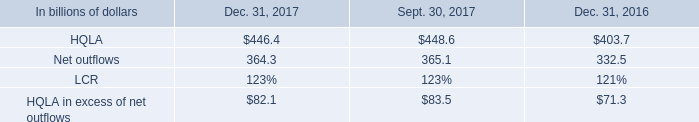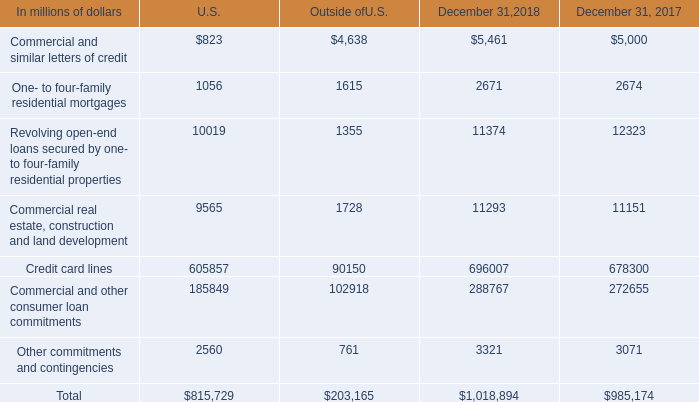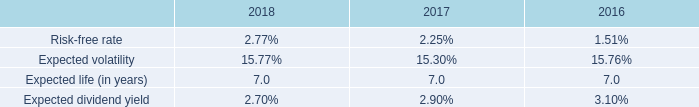what was the percentage increase in the net outflows from 2016 to 2017 
Computations: ((364.3 - 332.5) / 332.5)
Answer: 0.09564. 